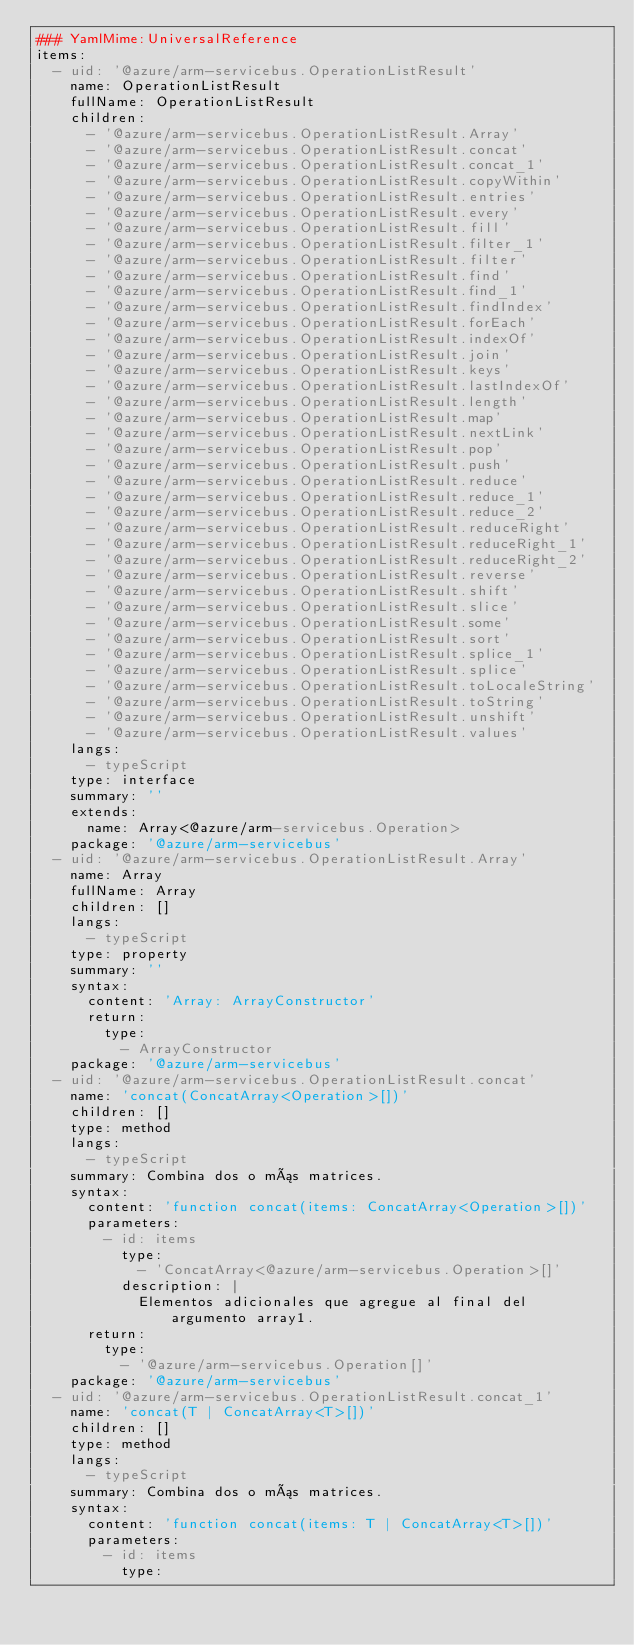Convert code to text. <code><loc_0><loc_0><loc_500><loc_500><_YAML_>### YamlMime:UniversalReference
items:
  - uid: '@azure/arm-servicebus.OperationListResult'
    name: OperationListResult
    fullName: OperationListResult
    children:
      - '@azure/arm-servicebus.OperationListResult.Array'
      - '@azure/arm-servicebus.OperationListResult.concat'
      - '@azure/arm-servicebus.OperationListResult.concat_1'
      - '@azure/arm-servicebus.OperationListResult.copyWithin'
      - '@azure/arm-servicebus.OperationListResult.entries'
      - '@azure/arm-servicebus.OperationListResult.every'
      - '@azure/arm-servicebus.OperationListResult.fill'
      - '@azure/arm-servicebus.OperationListResult.filter_1'
      - '@azure/arm-servicebus.OperationListResult.filter'
      - '@azure/arm-servicebus.OperationListResult.find'
      - '@azure/arm-servicebus.OperationListResult.find_1'
      - '@azure/arm-servicebus.OperationListResult.findIndex'
      - '@azure/arm-servicebus.OperationListResult.forEach'
      - '@azure/arm-servicebus.OperationListResult.indexOf'
      - '@azure/arm-servicebus.OperationListResult.join'
      - '@azure/arm-servicebus.OperationListResult.keys'
      - '@azure/arm-servicebus.OperationListResult.lastIndexOf'
      - '@azure/arm-servicebus.OperationListResult.length'
      - '@azure/arm-servicebus.OperationListResult.map'
      - '@azure/arm-servicebus.OperationListResult.nextLink'
      - '@azure/arm-servicebus.OperationListResult.pop'
      - '@azure/arm-servicebus.OperationListResult.push'
      - '@azure/arm-servicebus.OperationListResult.reduce'
      - '@azure/arm-servicebus.OperationListResult.reduce_1'
      - '@azure/arm-servicebus.OperationListResult.reduce_2'
      - '@azure/arm-servicebus.OperationListResult.reduceRight'
      - '@azure/arm-servicebus.OperationListResult.reduceRight_1'
      - '@azure/arm-servicebus.OperationListResult.reduceRight_2'
      - '@azure/arm-servicebus.OperationListResult.reverse'
      - '@azure/arm-servicebus.OperationListResult.shift'
      - '@azure/arm-servicebus.OperationListResult.slice'
      - '@azure/arm-servicebus.OperationListResult.some'
      - '@azure/arm-servicebus.OperationListResult.sort'
      - '@azure/arm-servicebus.OperationListResult.splice_1'
      - '@azure/arm-servicebus.OperationListResult.splice'
      - '@azure/arm-servicebus.OperationListResult.toLocaleString'
      - '@azure/arm-servicebus.OperationListResult.toString'
      - '@azure/arm-servicebus.OperationListResult.unshift'
      - '@azure/arm-servicebus.OperationListResult.values'
    langs:
      - typeScript
    type: interface
    summary: ''
    extends:
      name: Array<@azure/arm-servicebus.Operation>
    package: '@azure/arm-servicebus'
  - uid: '@azure/arm-servicebus.OperationListResult.Array'
    name: Array
    fullName: Array
    children: []
    langs:
      - typeScript
    type: property
    summary: ''
    syntax:
      content: 'Array: ArrayConstructor'
      return:
        type:
          - ArrayConstructor
    package: '@azure/arm-servicebus'
  - uid: '@azure/arm-servicebus.OperationListResult.concat'
    name: 'concat(ConcatArray<Operation>[])'
    children: []
    type: method
    langs:
      - typeScript
    summary: Combina dos o más matrices.
    syntax:
      content: 'function concat(items: ConcatArray<Operation>[])'
      parameters:
        - id: items
          type:
            - 'ConcatArray<@azure/arm-servicebus.Operation>[]'
          description: |
            Elementos adicionales que agregue al final del argumento array1.
      return:
        type:
          - '@azure/arm-servicebus.Operation[]'
    package: '@azure/arm-servicebus'
  - uid: '@azure/arm-servicebus.OperationListResult.concat_1'
    name: 'concat(T | ConcatArray<T>[])'
    children: []
    type: method
    langs:
      - typeScript
    summary: Combina dos o más matrices.
    syntax:
      content: 'function concat(items: T | ConcatArray<T>[])'
      parameters:
        - id: items
          type:</code> 